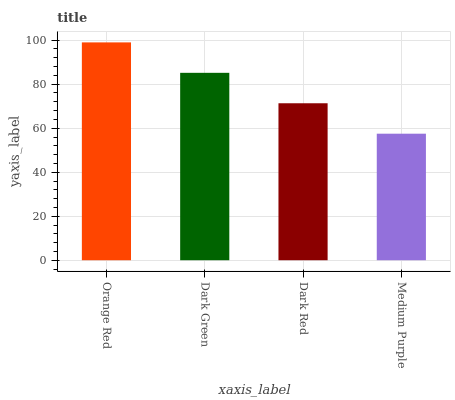Is Medium Purple the minimum?
Answer yes or no. Yes. Is Orange Red the maximum?
Answer yes or no. Yes. Is Dark Green the minimum?
Answer yes or no. No. Is Dark Green the maximum?
Answer yes or no. No. Is Orange Red greater than Dark Green?
Answer yes or no. Yes. Is Dark Green less than Orange Red?
Answer yes or no. Yes. Is Dark Green greater than Orange Red?
Answer yes or no. No. Is Orange Red less than Dark Green?
Answer yes or no. No. Is Dark Green the high median?
Answer yes or no. Yes. Is Dark Red the low median?
Answer yes or no. Yes. Is Medium Purple the high median?
Answer yes or no. No. Is Medium Purple the low median?
Answer yes or no. No. 